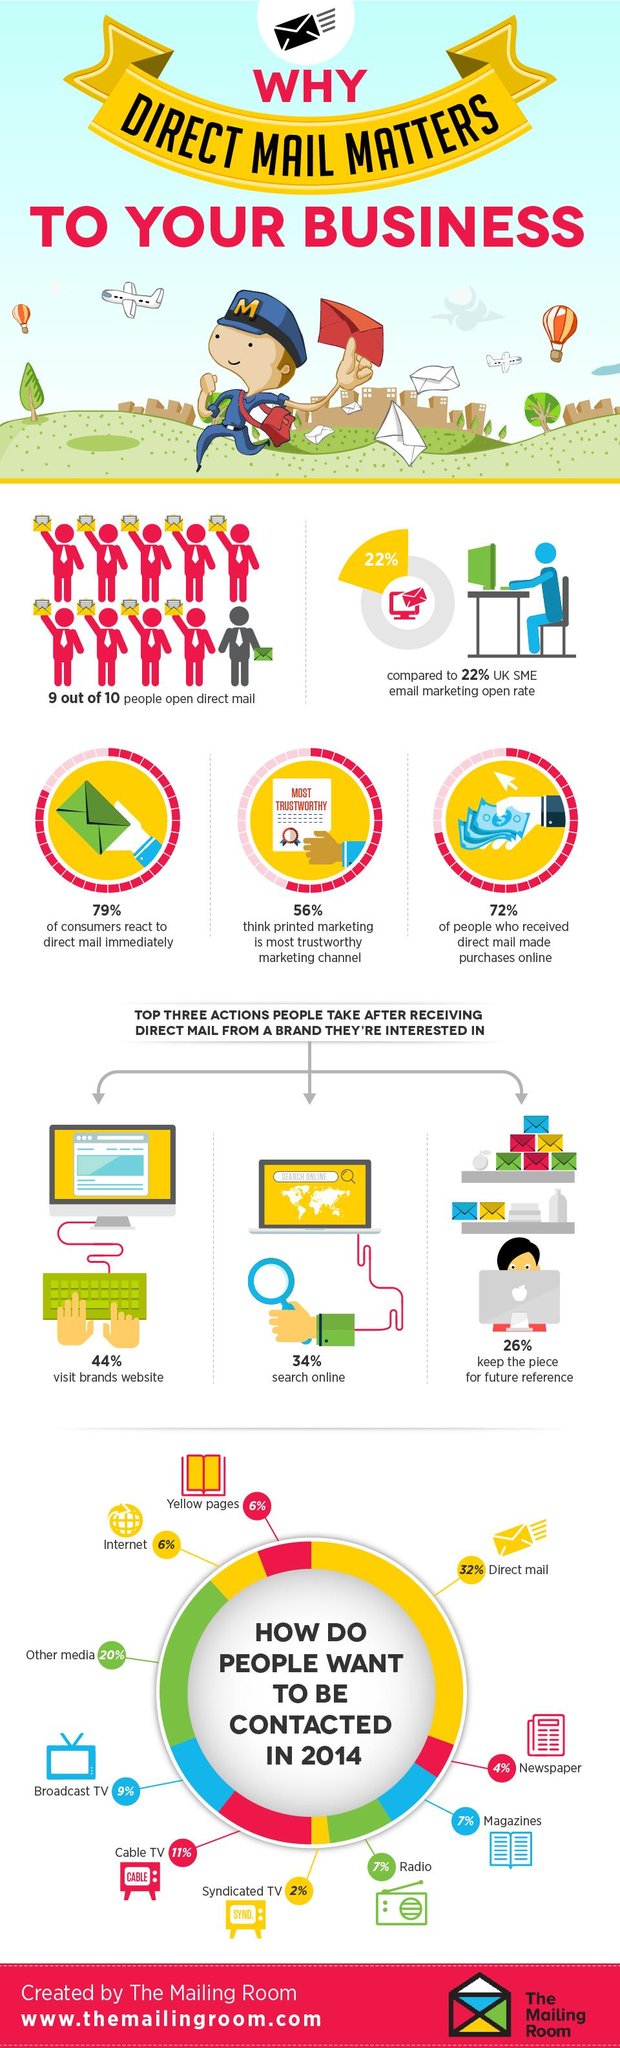Mention a couple of crucial points in this snapshot. According to a survey, 56% of people believe that printed marketing is the most trustworthy marketing channel. In 2014, the majority of people preferred to be contacted through direct mail. 44% of people visit a brand's website after receiving direct mail from the brand that they are interested in. In 2014, a significant portion of the population, approximately 6%, desired to be contacted through the internet. In 2014, only 4% of people desired to be contacted through the newspaper. 